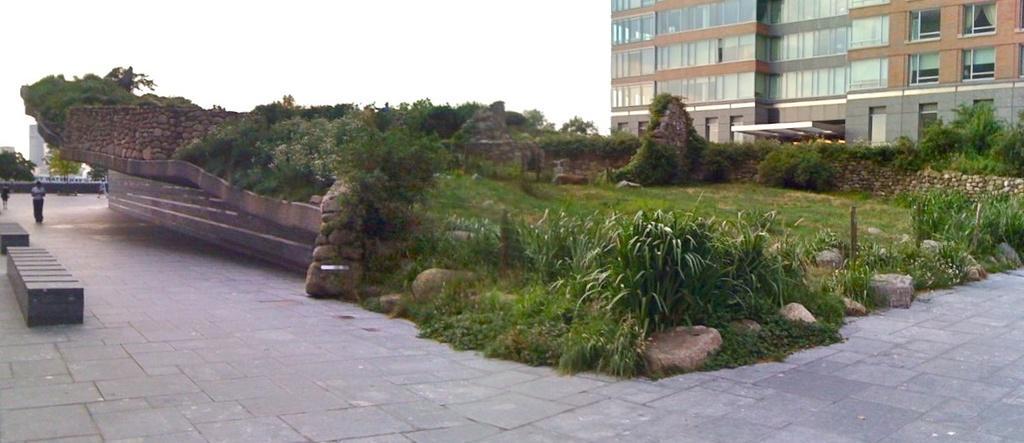Could you give a brief overview of what you see in this image? In this image I can see on the left side maybe there is a person walking on the floor. In the middle there are plants, on the right side there is a building, at the top there is the sky. 